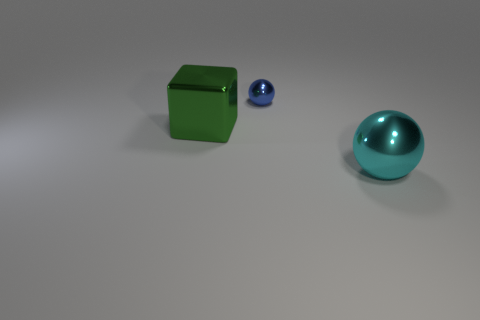Add 2 blue metallic cylinders. How many objects exist? 5 Subtract all blocks. How many objects are left? 2 Subtract 0 purple blocks. How many objects are left? 3 Subtract all green objects. Subtract all big green metallic objects. How many objects are left? 1 Add 1 big cyan shiny things. How many big cyan shiny things are left? 2 Add 3 large metal objects. How many large metal objects exist? 5 